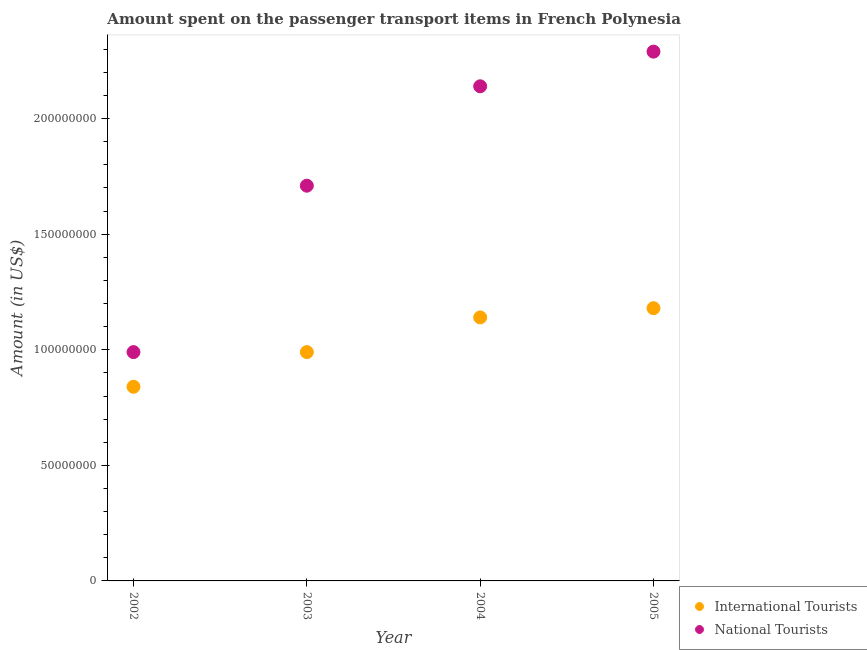How many different coloured dotlines are there?
Make the answer very short. 2. Is the number of dotlines equal to the number of legend labels?
Your answer should be very brief. Yes. What is the amount spent on transport items of international tourists in 2002?
Your answer should be compact. 8.40e+07. Across all years, what is the maximum amount spent on transport items of international tourists?
Your answer should be very brief. 1.18e+08. Across all years, what is the minimum amount spent on transport items of international tourists?
Provide a short and direct response. 8.40e+07. What is the total amount spent on transport items of national tourists in the graph?
Your response must be concise. 7.13e+08. What is the difference between the amount spent on transport items of national tourists in 2002 and that in 2003?
Provide a short and direct response. -7.20e+07. What is the difference between the amount spent on transport items of national tourists in 2003 and the amount spent on transport items of international tourists in 2002?
Keep it short and to the point. 8.70e+07. What is the average amount spent on transport items of international tourists per year?
Make the answer very short. 1.04e+08. In the year 2005, what is the difference between the amount spent on transport items of international tourists and amount spent on transport items of national tourists?
Give a very brief answer. -1.11e+08. What is the ratio of the amount spent on transport items of international tourists in 2004 to that in 2005?
Provide a succinct answer. 0.97. Is the amount spent on transport items of national tourists in 2004 less than that in 2005?
Ensure brevity in your answer.  Yes. Is the difference between the amount spent on transport items of international tourists in 2002 and 2005 greater than the difference between the amount spent on transport items of national tourists in 2002 and 2005?
Give a very brief answer. Yes. What is the difference between the highest and the second highest amount spent on transport items of international tourists?
Keep it short and to the point. 4.00e+06. What is the difference between the highest and the lowest amount spent on transport items of international tourists?
Offer a terse response. 3.40e+07. In how many years, is the amount spent on transport items of international tourists greater than the average amount spent on transport items of international tourists taken over all years?
Ensure brevity in your answer.  2. How many dotlines are there?
Provide a succinct answer. 2. Does the graph contain grids?
Offer a very short reply. No. How are the legend labels stacked?
Your response must be concise. Vertical. What is the title of the graph?
Your answer should be compact. Amount spent on the passenger transport items in French Polynesia. What is the label or title of the X-axis?
Keep it short and to the point. Year. What is the Amount (in US$) in International Tourists in 2002?
Provide a short and direct response. 8.40e+07. What is the Amount (in US$) of National Tourists in 2002?
Your answer should be very brief. 9.90e+07. What is the Amount (in US$) of International Tourists in 2003?
Provide a short and direct response. 9.90e+07. What is the Amount (in US$) of National Tourists in 2003?
Provide a succinct answer. 1.71e+08. What is the Amount (in US$) in International Tourists in 2004?
Ensure brevity in your answer.  1.14e+08. What is the Amount (in US$) of National Tourists in 2004?
Offer a very short reply. 2.14e+08. What is the Amount (in US$) of International Tourists in 2005?
Your response must be concise. 1.18e+08. What is the Amount (in US$) of National Tourists in 2005?
Provide a short and direct response. 2.29e+08. Across all years, what is the maximum Amount (in US$) of International Tourists?
Your answer should be very brief. 1.18e+08. Across all years, what is the maximum Amount (in US$) of National Tourists?
Your answer should be very brief. 2.29e+08. Across all years, what is the minimum Amount (in US$) in International Tourists?
Your answer should be very brief. 8.40e+07. Across all years, what is the minimum Amount (in US$) of National Tourists?
Make the answer very short. 9.90e+07. What is the total Amount (in US$) in International Tourists in the graph?
Keep it short and to the point. 4.15e+08. What is the total Amount (in US$) of National Tourists in the graph?
Keep it short and to the point. 7.13e+08. What is the difference between the Amount (in US$) of International Tourists in 2002 and that in 2003?
Ensure brevity in your answer.  -1.50e+07. What is the difference between the Amount (in US$) in National Tourists in 2002 and that in 2003?
Keep it short and to the point. -7.20e+07. What is the difference between the Amount (in US$) of International Tourists in 2002 and that in 2004?
Your answer should be compact. -3.00e+07. What is the difference between the Amount (in US$) of National Tourists in 2002 and that in 2004?
Provide a short and direct response. -1.15e+08. What is the difference between the Amount (in US$) in International Tourists in 2002 and that in 2005?
Keep it short and to the point. -3.40e+07. What is the difference between the Amount (in US$) of National Tourists in 2002 and that in 2005?
Make the answer very short. -1.30e+08. What is the difference between the Amount (in US$) in International Tourists in 2003 and that in 2004?
Keep it short and to the point. -1.50e+07. What is the difference between the Amount (in US$) of National Tourists in 2003 and that in 2004?
Keep it short and to the point. -4.30e+07. What is the difference between the Amount (in US$) in International Tourists in 2003 and that in 2005?
Ensure brevity in your answer.  -1.90e+07. What is the difference between the Amount (in US$) of National Tourists in 2003 and that in 2005?
Your answer should be very brief. -5.80e+07. What is the difference between the Amount (in US$) of National Tourists in 2004 and that in 2005?
Keep it short and to the point. -1.50e+07. What is the difference between the Amount (in US$) in International Tourists in 2002 and the Amount (in US$) in National Tourists in 2003?
Your answer should be compact. -8.70e+07. What is the difference between the Amount (in US$) in International Tourists in 2002 and the Amount (in US$) in National Tourists in 2004?
Keep it short and to the point. -1.30e+08. What is the difference between the Amount (in US$) of International Tourists in 2002 and the Amount (in US$) of National Tourists in 2005?
Keep it short and to the point. -1.45e+08. What is the difference between the Amount (in US$) of International Tourists in 2003 and the Amount (in US$) of National Tourists in 2004?
Provide a succinct answer. -1.15e+08. What is the difference between the Amount (in US$) of International Tourists in 2003 and the Amount (in US$) of National Tourists in 2005?
Offer a very short reply. -1.30e+08. What is the difference between the Amount (in US$) in International Tourists in 2004 and the Amount (in US$) in National Tourists in 2005?
Your response must be concise. -1.15e+08. What is the average Amount (in US$) of International Tourists per year?
Keep it short and to the point. 1.04e+08. What is the average Amount (in US$) in National Tourists per year?
Provide a short and direct response. 1.78e+08. In the year 2002, what is the difference between the Amount (in US$) in International Tourists and Amount (in US$) in National Tourists?
Your response must be concise. -1.50e+07. In the year 2003, what is the difference between the Amount (in US$) in International Tourists and Amount (in US$) in National Tourists?
Give a very brief answer. -7.20e+07. In the year 2004, what is the difference between the Amount (in US$) in International Tourists and Amount (in US$) in National Tourists?
Offer a terse response. -1.00e+08. In the year 2005, what is the difference between the Amount (in US$) of International Tourists and Amount (in US$) of National Tourists?
Offer a very short reply. -1.11e+08. What is the ratio of the Amount (in US$) in International Tourists in 2002 to that in 2003?
Your response must be concise. 0.85. What is the ratio of the Amount (in US$) in National Tourists in 2002 to that in 2003?
Provide a short and direct response. 0.58. What is the ratio of the Amount (in US$) in International Tourists in 2002 to that in 2004?
Ensure brevity in your answer.  0.74. What is the ratio of the Amount (in US$) of National Tourists in 2002 to that in 2004?
Your answer should be compact. 0.46. What is the ratio of the Amount (in US$) of International Tourists in 2002 to that in 2005?
Make the answer very short. 0.71. What is the ratio of the Amount (in US$) in National Tourists in 2002 to that in 2005?
Keep it short and to the point. 0.43. What is the ratio of the Amount (in US$) in International Tourists in 2003 to that in 2004?
Provide a short and direct response. 0.87. What is the ratio of the Amount (in US$) of National Tourists in 2003 to that in 2004?
Offer a very short reply. 0.8. What is the ratio of the Amount (in US$) in International Tourists in 2003 to that in 2005?
Give a very brief answer. 0.84. What is the ratio of the Amount (in US$) in National Tourists in 2003 to that in 2005?
Keep it short and to the point. 0.75. What is the ratio of the Amount (in US$) in International Tourists in 2004 to that in 2005?
Offer a very short reply. 0.97. What is the ratio of the Amount (in US$) in National Tourists in 2004 to that in 2005?
Ensure brevity in your answer.  0.93. What is the difference between the highest and the second highest Amount (in US$) of National Tourists?
Provide a short and direct response. 1.50e+07. What is the difference between the highest and the lowest Amount (in US$) of International Tourists?
Provide a succinct answer. 3.40e+07. What is the difference between the highest and the lowest Amount (in US$) in National Tourists?
Your answer should be very brief. 1.30e+08. 